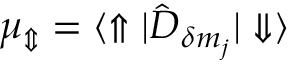Convert formula to latex. <formula><loc_0><loc_0><loc_500><loc_500>{ \mu _ { \Updownarrow } = { \langle \Uparrow | \hat { D } _ { \delta m _ { j } } | \Downarrow \rangle } }</formula> 